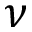Convert formula to latex. <formula><loc_0><loc_0><loc_500><loc_500>\nu</formula> 